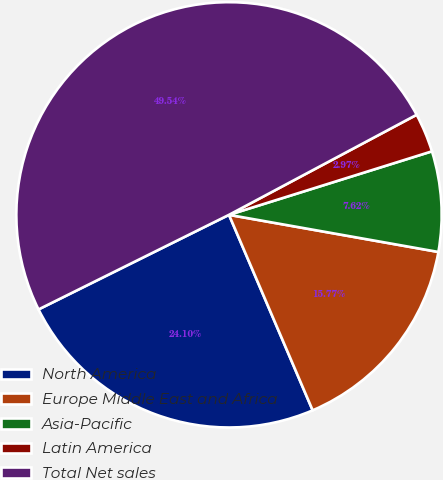<chart> <loc_0><loc_0><loc_500><loc_500><pie_chart><fcel>North America<fcel>Europe Middle East and Africa<fcel>Asia-Pacific<fcel>Latin America<fcel>Total Net sales<nl><fcel>24.1%<fcel>15.77%<fcel>7.62%<fcel>2.97%<fcel>49.54%<nl></chart> 